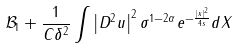Convert formula to latex. <formula><loc_0><loc_0><loc_500><loc_500>\mathcal { B } _ { 1 } + \frac { 1 } { C \delta ^ { 2 } } \int \left | D ^ { 2 } u \right | ^ { 2 } \sigma ^ { 1 - 2 \alpha } e ^ { - \frac { \left | x \right | ^ { 2 } } { 4 s } } d X</formula> 